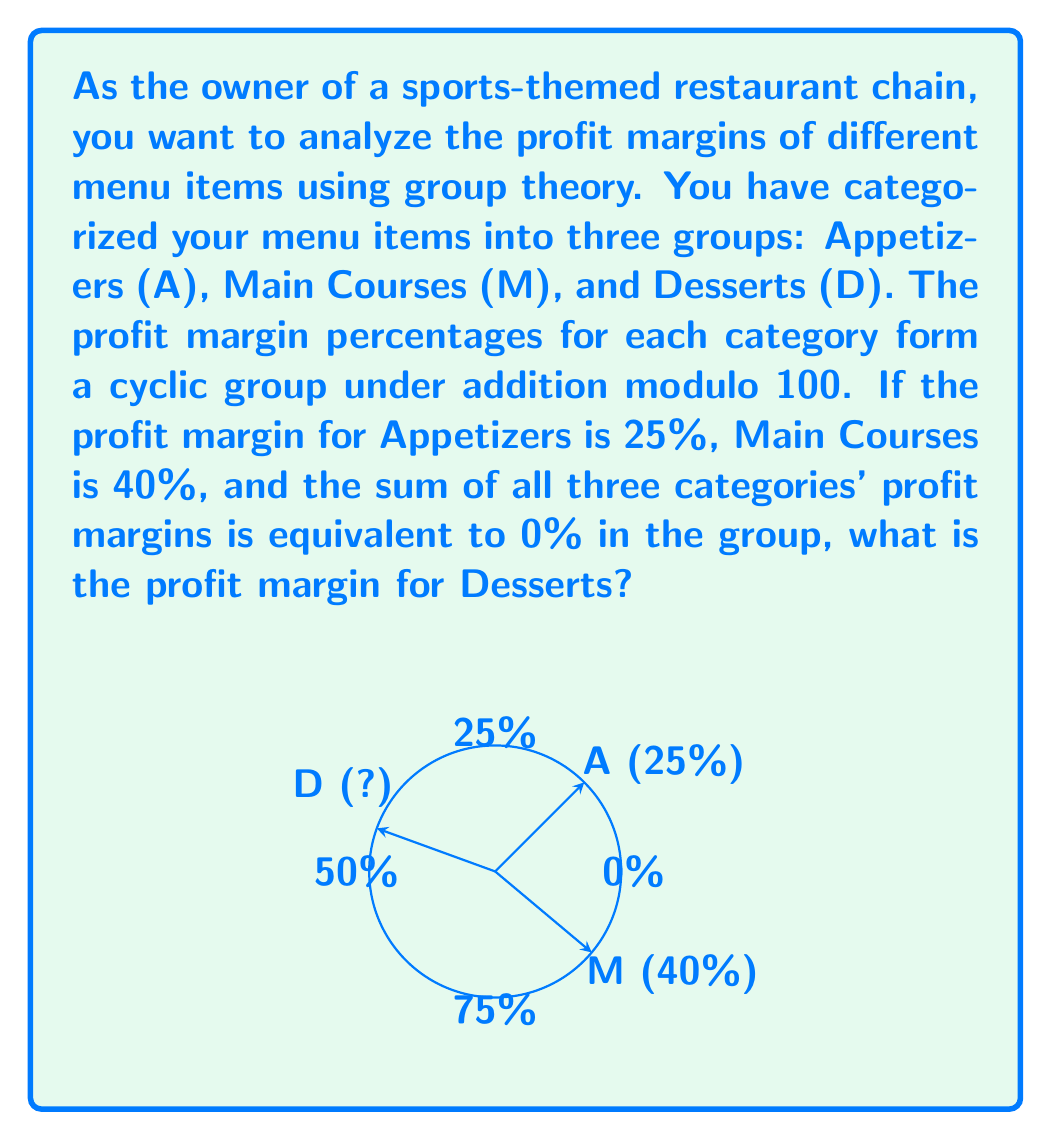Can you solve this math problem? Let's approach this step-by-step using group theory concepts:

1) We're working with a cyclic group under addition modulo 100. This means that all calculations are performed modulo 100.

2) Let's define our group operation as $\oplus$ to represent addition modulo 100.

3) We're given that:
   - Appetizers (A) = 25%
   - Main Courses (M) = 40%
   - Desserts (D) = unknown

4) We're also told that the sum of all three categories is equivalent to 0% in the group. This can be expressed as:

   $A \oplus M \oplus D \equiv 0 \pmod{100}$

5) Substituting the known values:

   $25 \oplus 40 \oplus D \equiv 0 \pmod{100}$

6) In modular arithmetic, this is equivalent to solving:

   $25 + 40 + D \equiv 0 \pmod{100}$

7) Simplifying:

   $65 + D \equiv 0 \pmod{100}$

8) To solve for D, we need to find a number that, when added to 65, gives a multiple of 100. That number is 35.

9) Therefore:

   $D \equiv 35 \pmod{100}$

So, the profit margin for Desserts is 35%.
Answer: 35% 